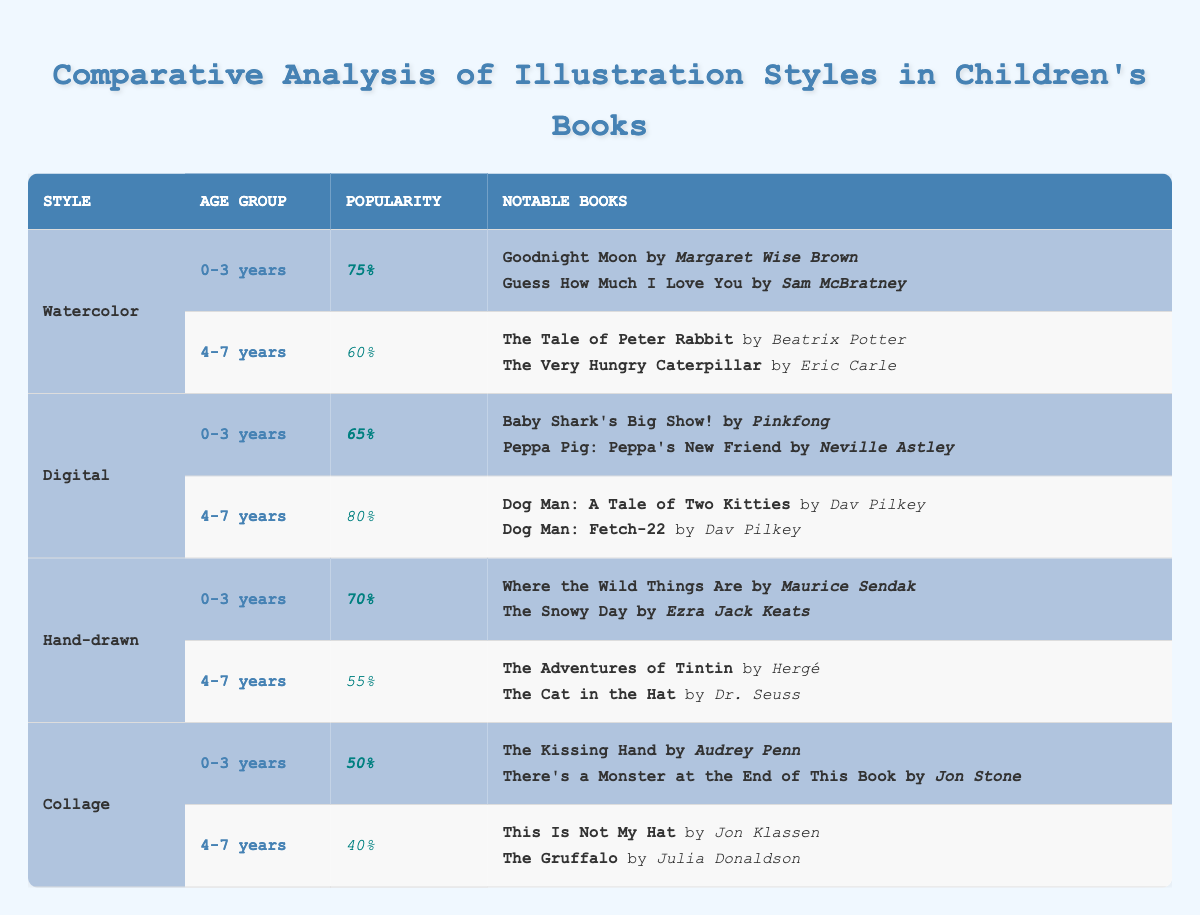What is the most popular illustration style for 0-3 years age group? The table shows that 'Watercolor' has the highest popularity score of 75% for the 0-3 years age group.
Answer: Watercolor Which illustration style has the lowest popularity for the 4-7 years age group? 'Collage' has the lowest popularity score of 40% for the 4-7 years age group compared to other styles listed.
Answer: Collage Are there any notable books listed for the 'Digital' illustration style for the 0-3 years age group? Yes, the notable books for 'Digital' in the 0-3 years group are "Baby Shark's Big Show!" by Pinkfong and "Peppa Pig: Peppa's New Friend" by Neville Astley, as mentioned in the table.
Answer: Yes What is the average popularity score for both age groups across all illustration styles? To find the average, first, calculate the total popularity for both age groups: (75 + 60 + 65 + 80 + 70 + 55 + 50 + 40) = 495. There are 8 data points, so the average is 495/8 = 61.875.
Answer: 61.875 Is 'Hand-drawn' illustration style more popular than 'Collage' for the 4-7 years age group? No, 'Hand-drawn' has a popularity of 55% while 'Collage' has a lower score of 40% for the 4-7 years group. Therefore, 'Hand-drawn' is indeed more popular than 'Collage' in that age group.
Answer: Yes What is the total number of notable books for the 'Watercolor' illustration style? For 'Watercolor', there are four notable books listed: "Goodnight Moon," "Guess How Much I Love You," "The Tale of Peter Rabbit," and "The Very Hungry Caterpillar." Hence, the total number is 4.
Answer: 4 How does the popularity of 'Digital' for the 4-7 years age group compare to that of 'Watercolor'? The popularity for 'Digital' is 80% while for 'Watercolor' it is 60%. The difference is 80 - 60 = 20, indicating that 'Digital' is 20% more popular than 'Watercolor' for this age group.
Answer: 20% more Which illustration style has a popularity score of 50% for the 0-3 years age group? According to the table, 'Collage' has a popularity score of 50% for the 0-3 years age group, as displayed.
Answer: Collage What is the difference in popularity between the 'Digital' style for 0-3 years and Hand-drawn style for 4-7 years? For 'Digital', the popularity is 65% for the 0-3 years group, and for 'Hand-drawn' in the 4-7 years group, it is 55%. The difference is 65 - 55 = 10.
Answer: 10 